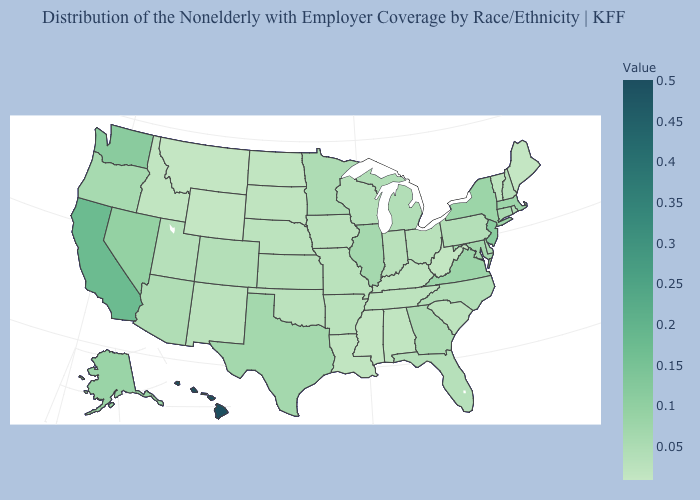Does Montana have the lowest value in the West?
Answer briefly. Yes. Which states have the lowest value in the Northeast?
Keep it brief. Maine. Does South Dakota have the lowest value in the USA?
Answer briefly. No. 